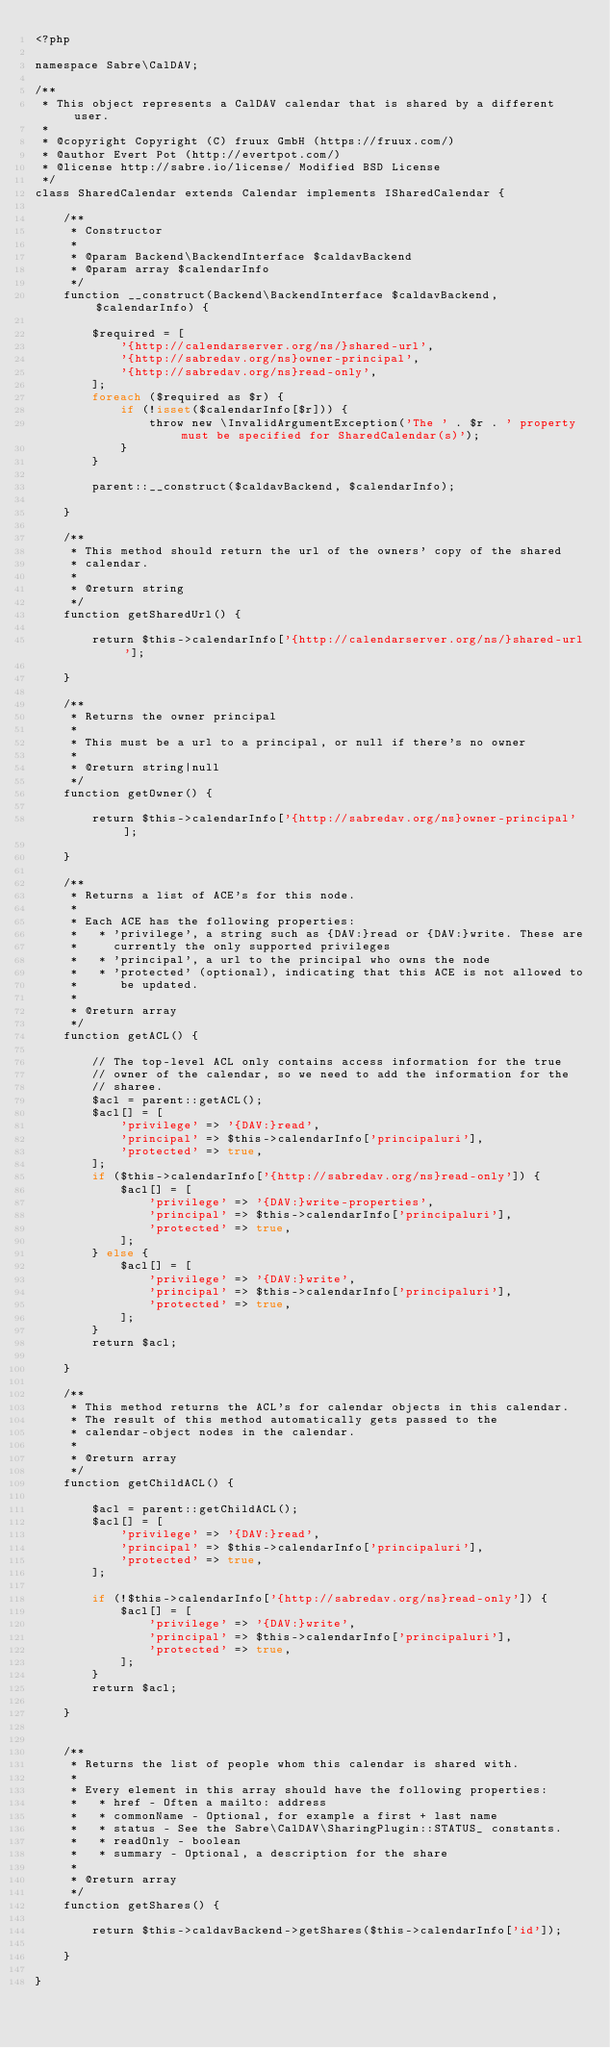<code> <loc_0><loc_0><loc_500><loc_500><_PHP_><?php

namespace Sabre\CalDAV;

/**
 * This object represents a CalDAV calendar that is shared by a different user.
 *
 * @copyright Copyright (C) fruux GmbH (https://fruux.com/)
 * @author Evert Pot (http://evertpot.com/)
 * @license http://sabre.io/license/ Modified BSD License
 */
class SharedCalendar extends Calendar implements ISharedCalendar {

    /**
     * Constructor
     *
     * @param Backend\BackendInterface $caldavBackend
     * @param array $calendarInfo
     */
    function __construct(Backend\BackendInterface $caldavBackend, $calendarInfo) {

        $required = [
            '{http://calendarserver.org/ns/}shared-url',
            '{http://sabredav.org/ns}owner-principal',
            '{http://sabredav.org/ns}read-only',
        ];
        foreach ($required as $r) {
            if (!isset($calendarInfo[$r])) {
                throw new \InvalidArgumentException('The ' . $r . ' property must be specified for SharedCalendar(s)');
            }
        }

        parent::__construct($caldavBackend, $calendarInfo);

    }

    /**
     * This method should return the url of the owners' copy of the shared
     * calendar.
     *
     * @return string
     */
    function getSharedUrl() {

        return $this->calendarInfo['{http://calendarserver.org/ns/}shared-url'];

    }

    /**
     * Returns the owner principal
     *
     * This must be a url to a principal, or null if there's no owner
     *
     * @return string|null
     */
    function getOwner() {

        return $this->calendarInfo['{http://sabredav.org/ns}owner-principal'];

    }

    /**
     * Returns a list of ACE's for this node.
     *
     * Each ACE has the following properties:
     *   * 'privilege', a string such as {DAV:}read or {DAV:}write. These are
     *     currently the only supported privileges
     *   * 'principal', a url to the principal who owns the node
     *   * 'protected' (optional), indicating that this ACE is not allowed to
     *      be updated.
     *
     * @return array
     */
    function getACL() {

        // The top-level ACL only contains access information for the true
        // owner of the calendar, so we need to add the information for the
        // sharee.
        $acl = parent::getACL();
        $acl[] = [
            'privilege' => '{DAV:}read',
            'principal' => $this->calendarInfo['principaluri'],
            'protected' => true,
        ];
        if ($this->calendarInfo['{http://sabredav.org/ns}read-only']) {
            $acl[] = [
                'privilege' => '{DAV:}write-properties',
                'principal' => $this->calendarInfo['principaluri'],
                'protected' => true,
            ];
        } else {
            $acl[] = [
                'privilege' => '{DAV:}write',
                'principal' => $this->calendarInfo['principaluri'],
                'protected' => true,
            ];
        }
        return $acl;

    }

    /**
     * This method returns the ACL's for calendar objects in this calendar.
     * The result of this method automatically gets passed to the
     * calendar-object nodes in the calendar.
     *
     * @return array
     */
    function getChildACL() {

        $acl = parent::getChildACL();
        $acl[] = [
            'privilege' => '{DAV:}read',
            'principal' => $this->calendarInfo['principaluri'],
            'protected' => true,
        ];

        if (!$this->calendarInfo['{http://sabredav.org/ns}read-only']) {
            $acl[] = [
                'privilege' => '{DAV:}write',
                'principal' => $this->calendarInfo['principaluri'],
                'protected' => true,
            ];
        }
        return $acl;

    }


    /**
     * Returns the list of people whom this calendar is shared with.
     *
     * Every element in this array should have the following properties:
     *   * href - Often a mailto: address
     *   * commonName - Optional, for example a first + last name
     *   * status - See the Sabre\CalDAV\SharingPlugin::STATUS_ constants.
     *   * readOnly - boolean
     *   * summary - Optional, a description for the share
     *
     * @return array
     */
    function getShares() {

        return $this->caldavBackend->getShares($this->calendarInfo['id']);

    }

}
</code> 